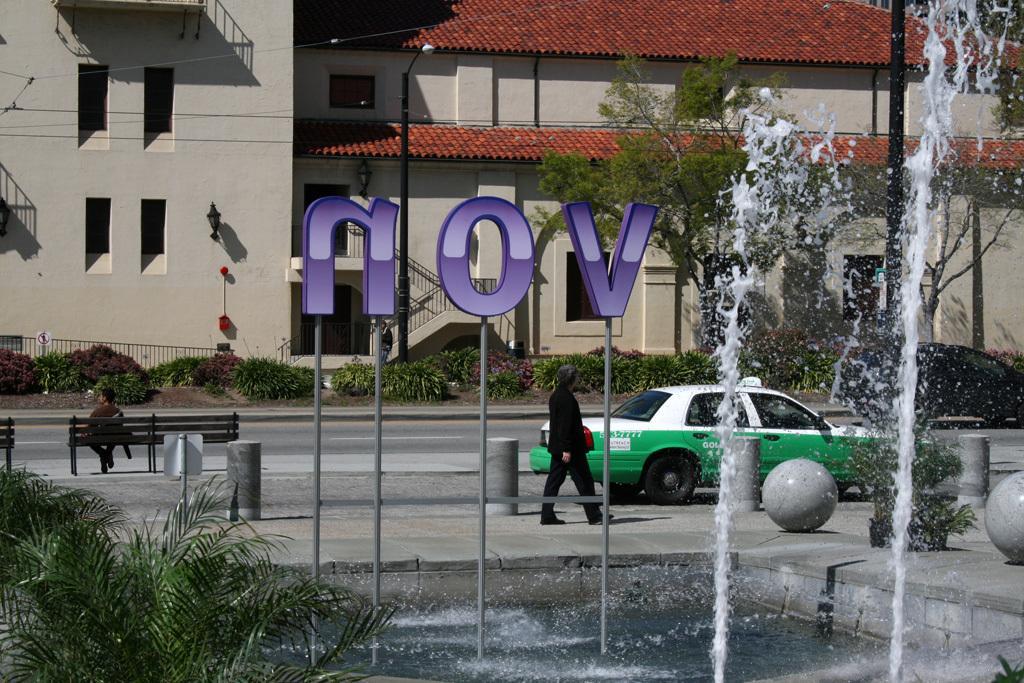How would you summarize this image in a sentence or two? In this image there is a building attached with light and in front there is a street light. At the bottom there is a grass and on it there are some plants. There is a road, and on the sidewalk there is a bench person sitting on it and the other person is walking with red color bag. And there are some plants beside the road and also a fountain and stones. 